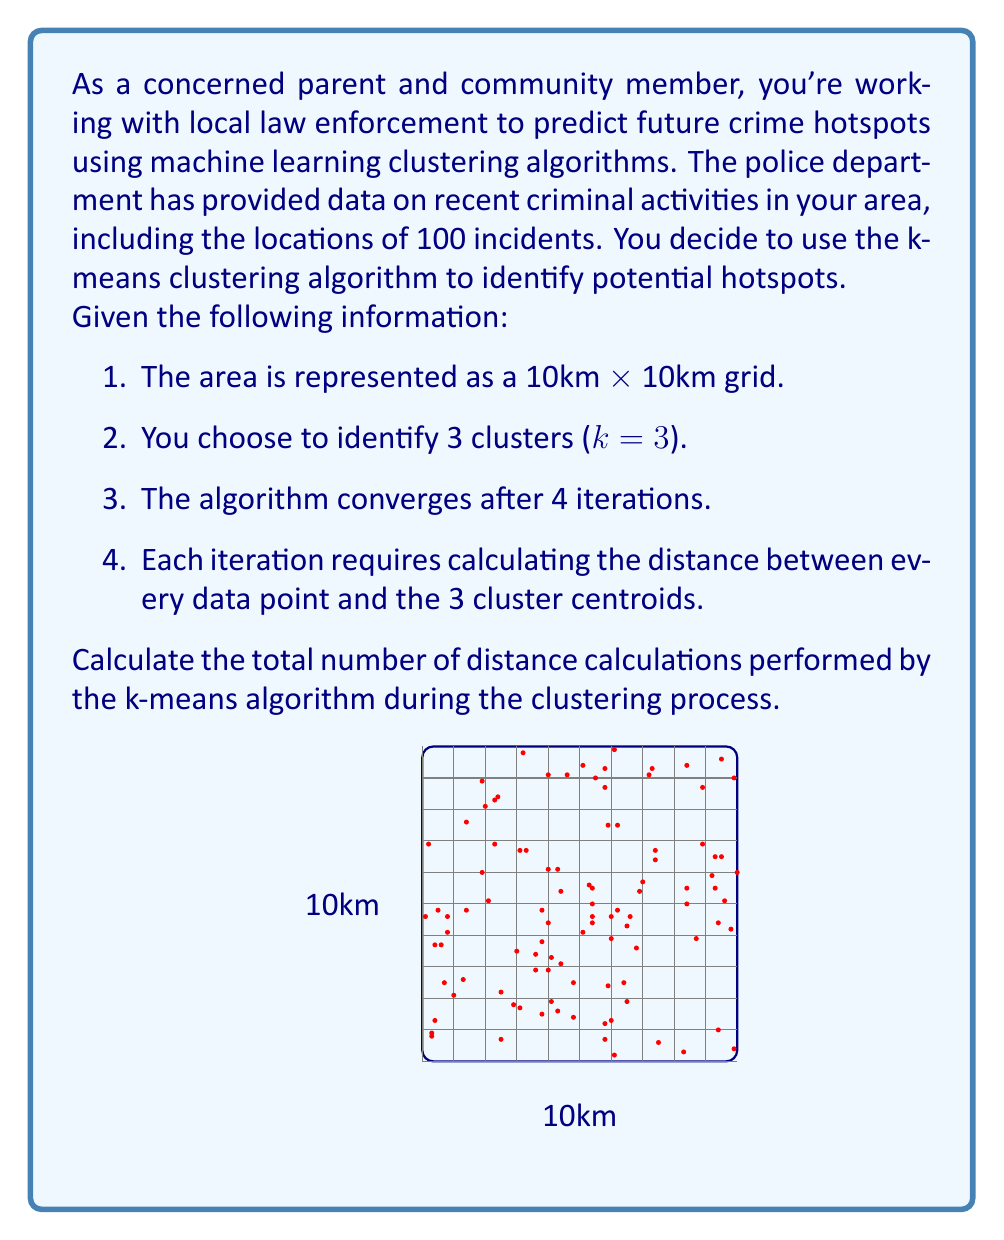Could you help me with this problem? Let's break this problem down step-by-step:

1) First, we need to understand what the k-means algorithm does in each iteration:
   - It calculates the distance between each data point and each cluster centroid.
   - Then it assigns each point to the nearest centroid.
   - Finally, it recalculates the centroids based on the new assignments.

2) In this problem, we're only concerned with the distance calculations:
   - We have 100 data points (incidents)
   - We have 3 clusters (k = 3)
   - The algorithm runs for 4 iterations

3) In each iteration, we calculate the distance from each point to each centroid:
   - Number of calculations per iteration = Number of points × Number of centroids
   - Number of calculations per iteration = 100 × 3 = 300

4) The total number of calculations is this number multiplied by the number of iterations:
   - Total calculations = Calculations per iteration × Number of iterations
   - Total calculations = 300 × 4 = 1200

Therefore, the k-means algorithm performs 1200 distance calculations in total during the clustering process.
Answer: 1200 distance calculations 